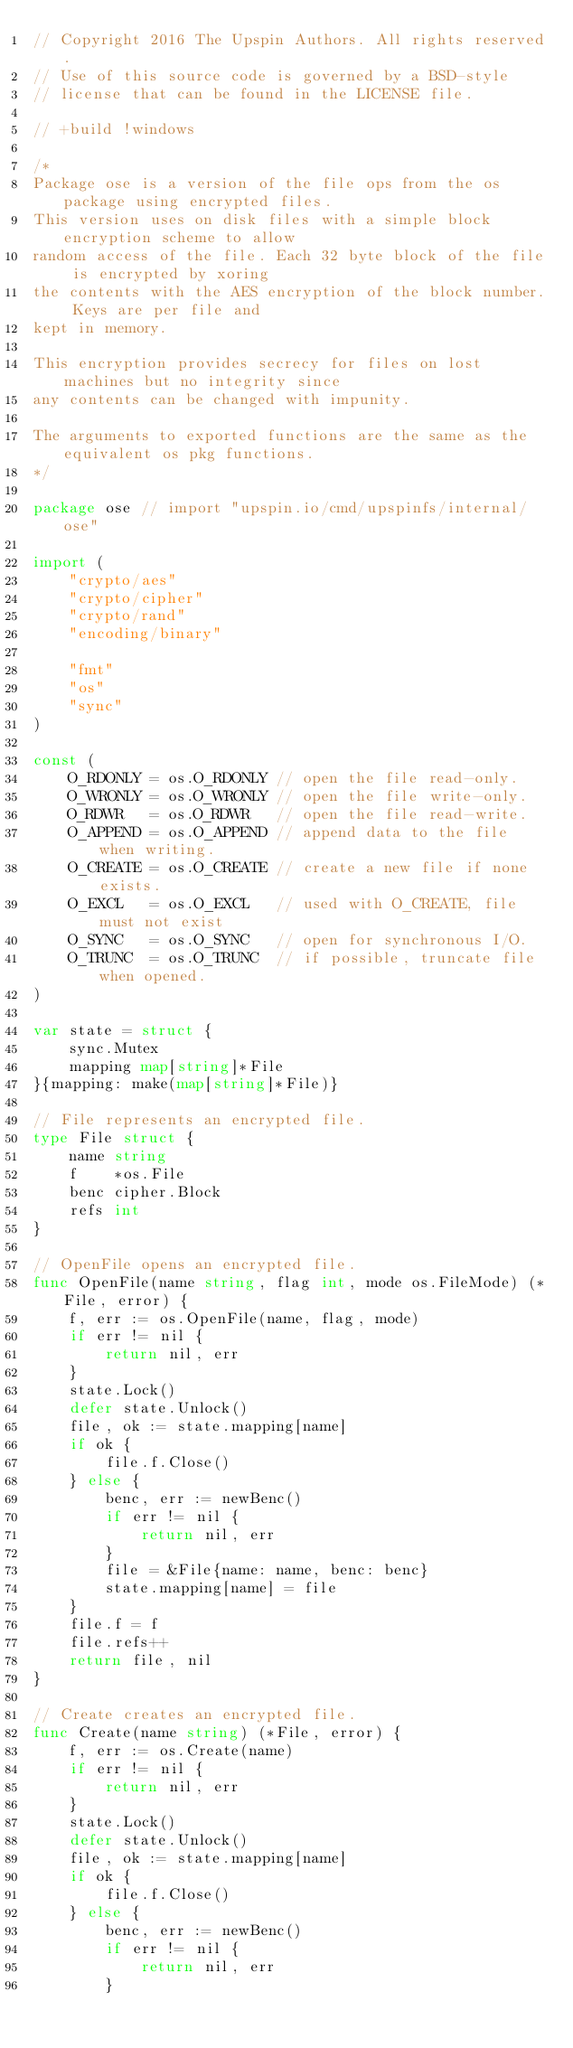Convert code to text. <code><loc_0><loc_0><loc_500><loc_500><_Go_>// Copyright 2016 The Upspin Authors. All rights reserved.
// Use of this source code is governed by a BSD-style
// license that can be found in the LICENSE file.

// +build !windows

/*
Package ose is a version of the file ops from the os package using encrypted files.
This version uses on disk files with a simple block encryption scheme to allow
random access of the file. Each 32 byte block of the file is encrypted by xoring
the contents with the AES encryption of the block number. Keys are per file and
kept in memory.

This encryption provides secrecy for files on lost machines but no integrity since
any contents can be changed with impunity.

The arguments to exported functions are the same as the equivalent os pkg functions.
*/

package ose // import "upspin.io/cmd/upspinfs/internal/ose"

import (
	"crypto/aes"
	"crypto/cipher"
	"crypto/rand"
	"encoding/binary"

	"fmt"
	"os"
	"sync"
)

const (
	O_RDONLY = os.O_RDONLY // open the file read-only.
	O_WRONLY = os.O_WRONLY // open the file write-only.
	O_RDWR   = os.O_RDWR   // open the file read-write.
	O_APPEND = os.O_APPEND // append data to the file when writing.
	O_CREATE = os.O_CREATE // create a new file if none exists.
	O_EXCL   = os.O_EXCL   // used with O_CREATE, file must not exist
	O_SYNC   = os.O_SYNC   // open for synchronous I/O.
	O_TRUNC  = os.O_TRUNC  // if possible, truncate file when opened.
)

var state = struct {
	sync.Mutex
	mapping map[string]*File
}{mapping: make(map[string]*File)}

// File represents an encrypted file.
type File struct {
	name string
	f    *os.File
	benc cipher.Block
	refs int
}

// OpenFile opens an encrypted file.
func OpenFile(name string, flag int, mode os.FileMode) (*File, error) {
	f, err := os.OpenFile(name, flag, mode)
	if err != nil {
		return nil, err
	}
	state.Lock()
	defer state.Unlock()
	file, ok := state.mapping[name]
	if ok {
		file.f.Close()
	} else {
		benc, err := newBenc()
		if err != nil {
			return nil, err
		}
		file = &File{name: name, benc: benc}
		state.mapping[name] = file
	}
	file.f = f
	file.refs++
	return file, nil
}

// Create creates an encrypted file.
func Create(name string) (*File, error) {
	f, err := os.Create(name)
	if err != nil {
		return nil, err
	}
	state.Lock()
	defer state.Unlock()
	file, ok := state.mapping[name]
	if ok {
		file.f.Close()
	} else {
		benc, err := newBenc()
		if err != nil {
			return nil, err
		}</code> 